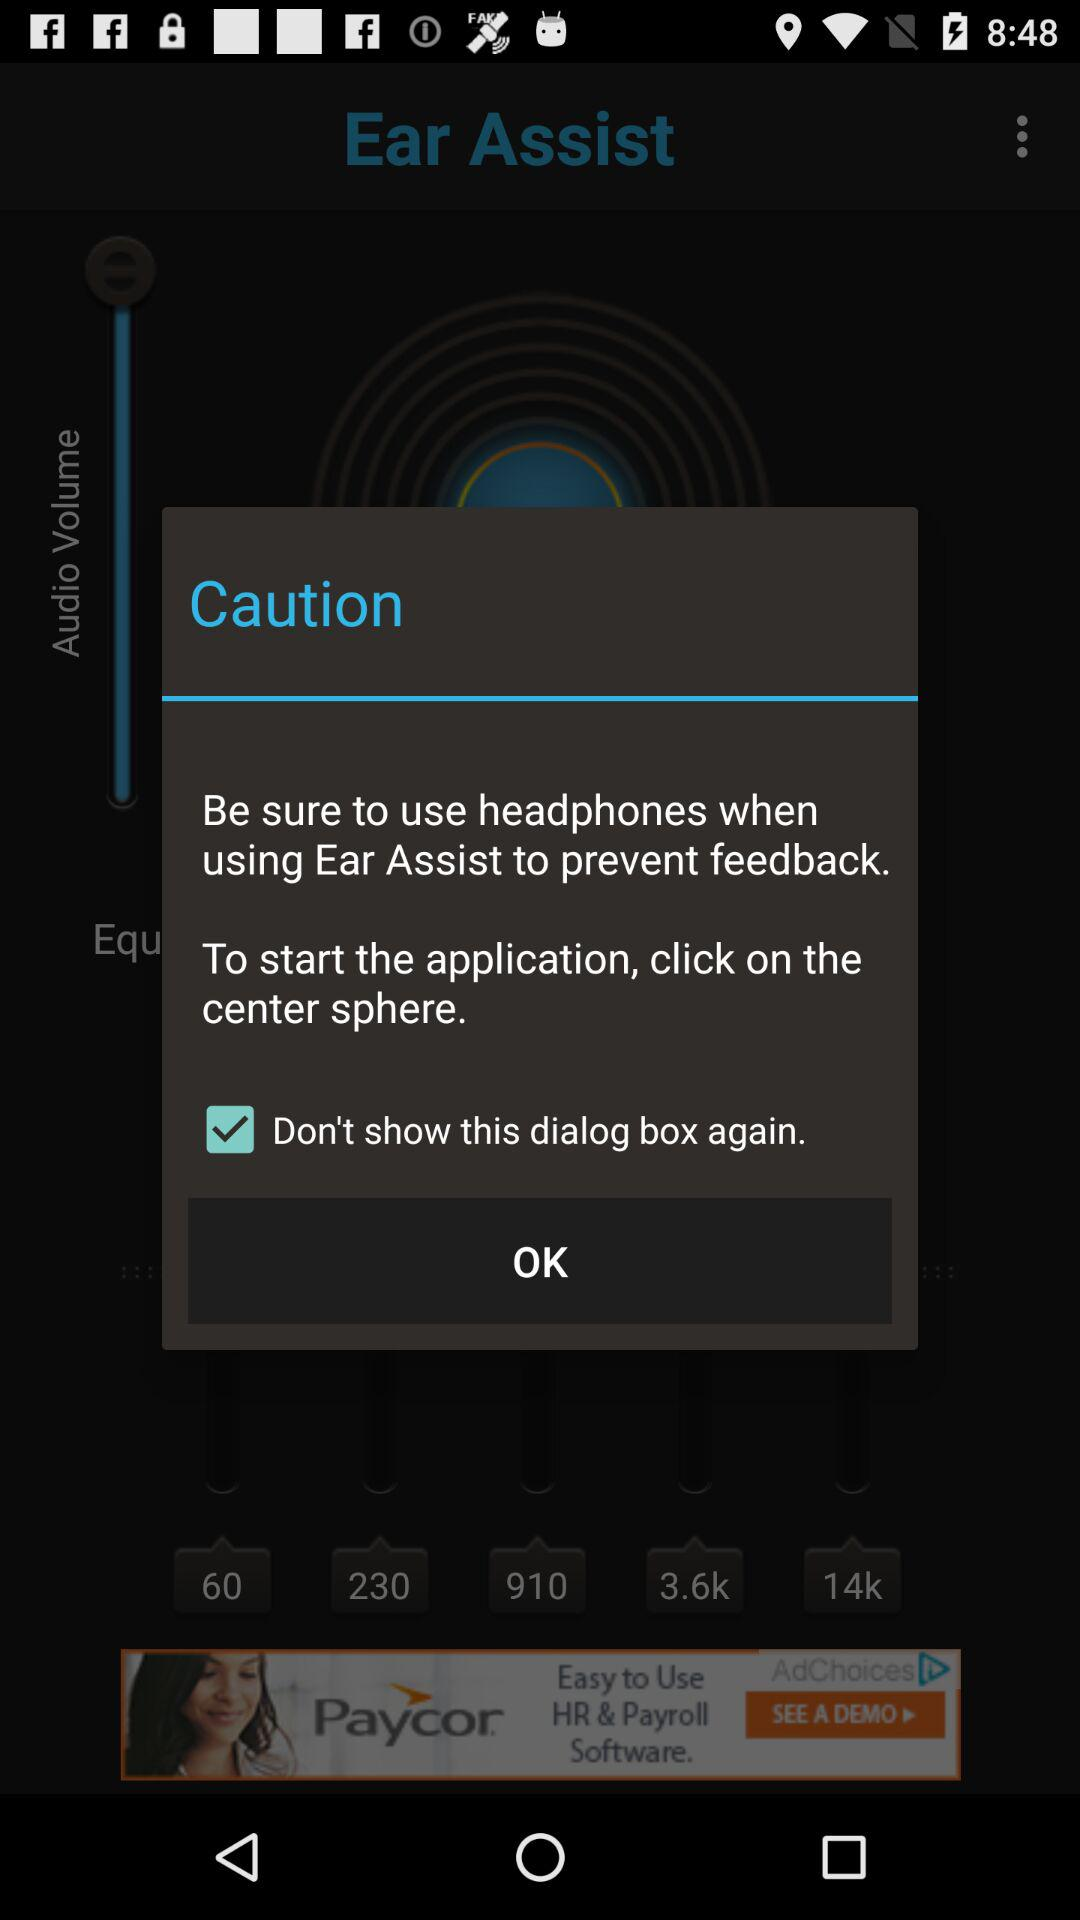What is the status of "Don't show this dialog box again"? The status is on. 